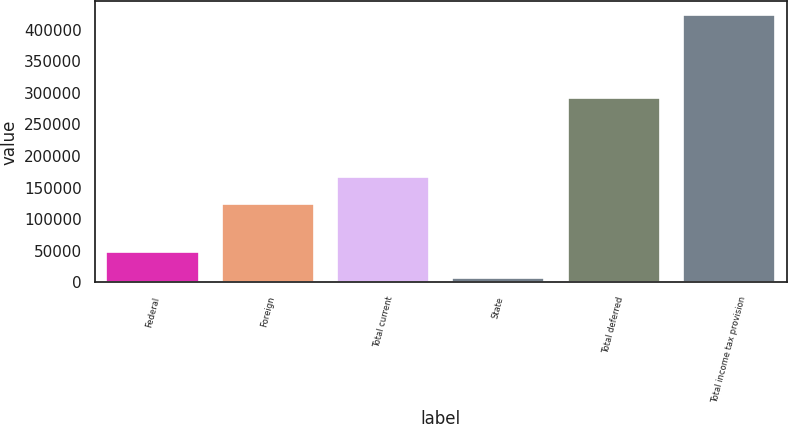Convert chart. <chart><loc_0><loc_0><loc_500><loc_500><bar_chart><fcel>Federal<fcel>Foreign<fcel>Total current<fcel>State<fcel>Total deferred<fcel>Total income tax provision<nl><fcel>48024.4<fcel>124901<fcel>166642<fcel>6283<fcel>291881<fcel>423697<nl></chart> 